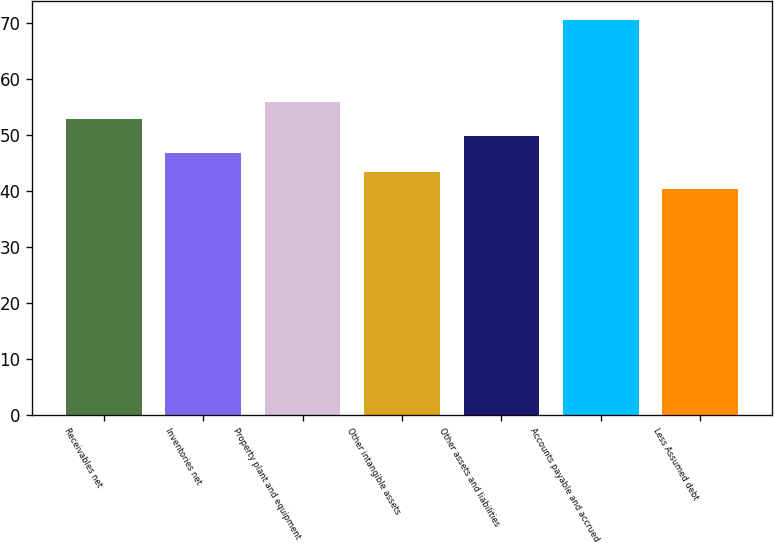Convert chart. <chart><loc_0><loc_0><loc_500><loc_500><bar_chart><fcel>Receivables net<fcel>Inventories net<fcel>Property plant and equipment<fcel>Other intangible assets<fcel>Other assets and liabilities<fcel>Accounts payable and accrued<fcel>Less Assumed debt<nl><fcel>52.82<fcel>46.8<fcel>55.83<fcel>43.31<fcel>49.81<fcel>70.4<fcel>40.3<nl></chart> 